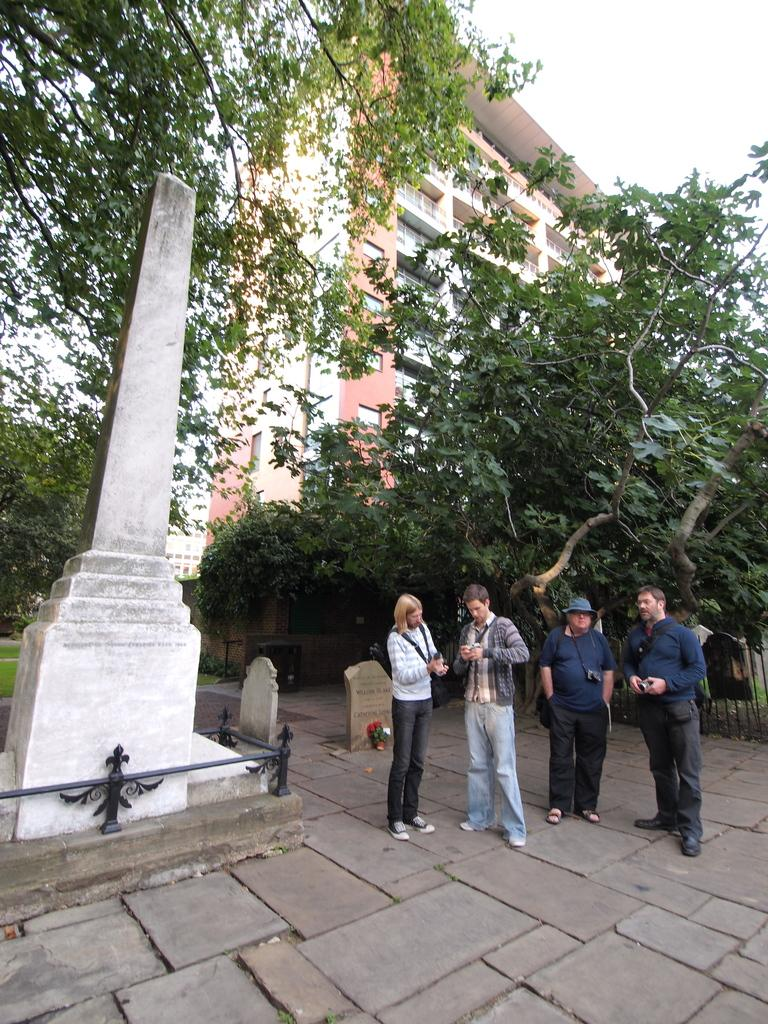How many people are standing on the road in the foreground? There are four persons standing on the road in the foreground. What is the setting of the image? The scene is in front of a cemetery. What can be seen in the background of the image? There are trees, at least one building, and the sky visible in the background of the image. When was the image taken? The image was taken during the day. What type of statement is being made by the car in the image? There is no car present in the image, so it is not possible to determine what statement might be made by a car. 